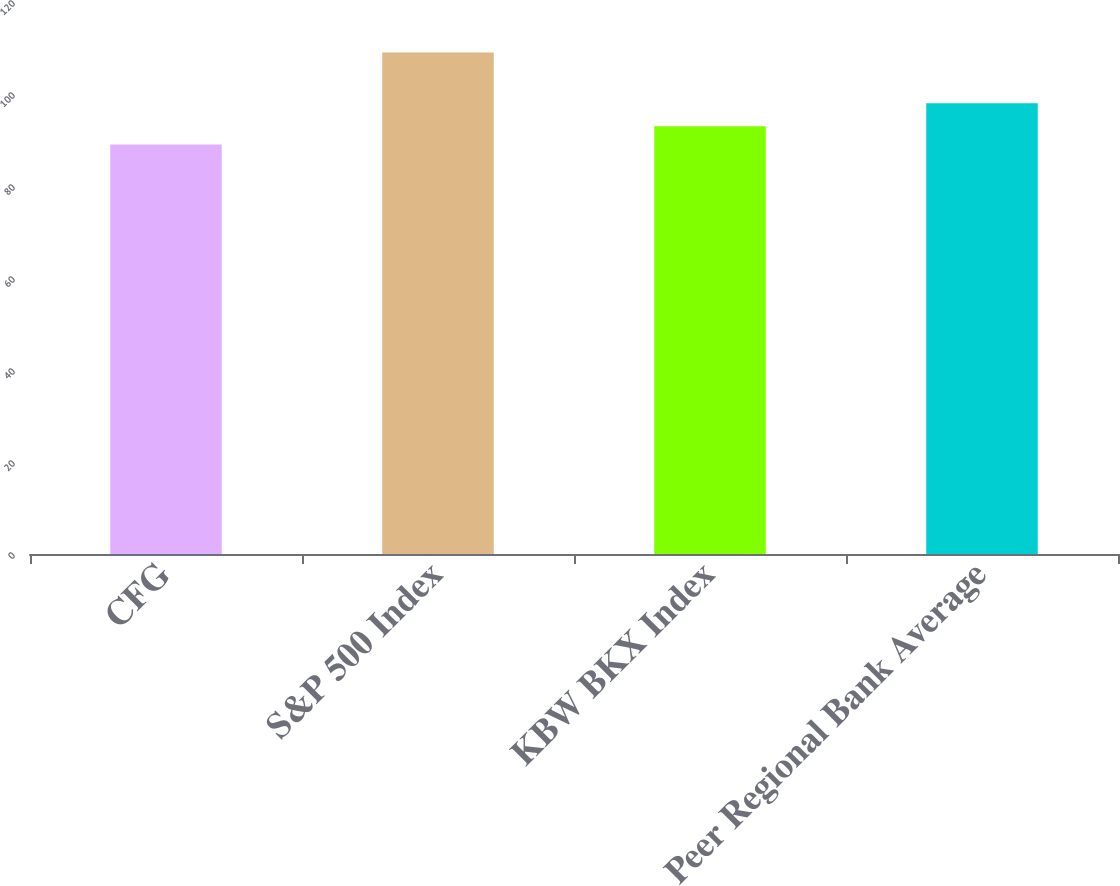<chart> <loc_0><loc_0><loc_500><loc_500><bar_chart><fcel>CFG<fcel>S&P 500 Index<fcel>KBW BKX Index<fcel>Peer Regional Bank Average<nl><fcel>89<fcel>109<fcel>93<fcel>98<nl></chart> 